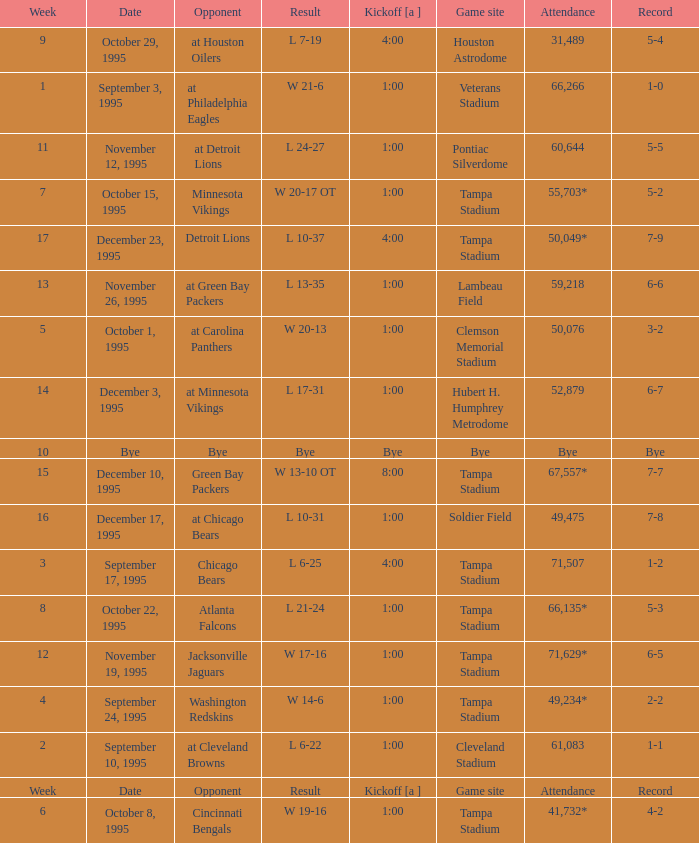What week was it on November 19, 1995? 12.0. 